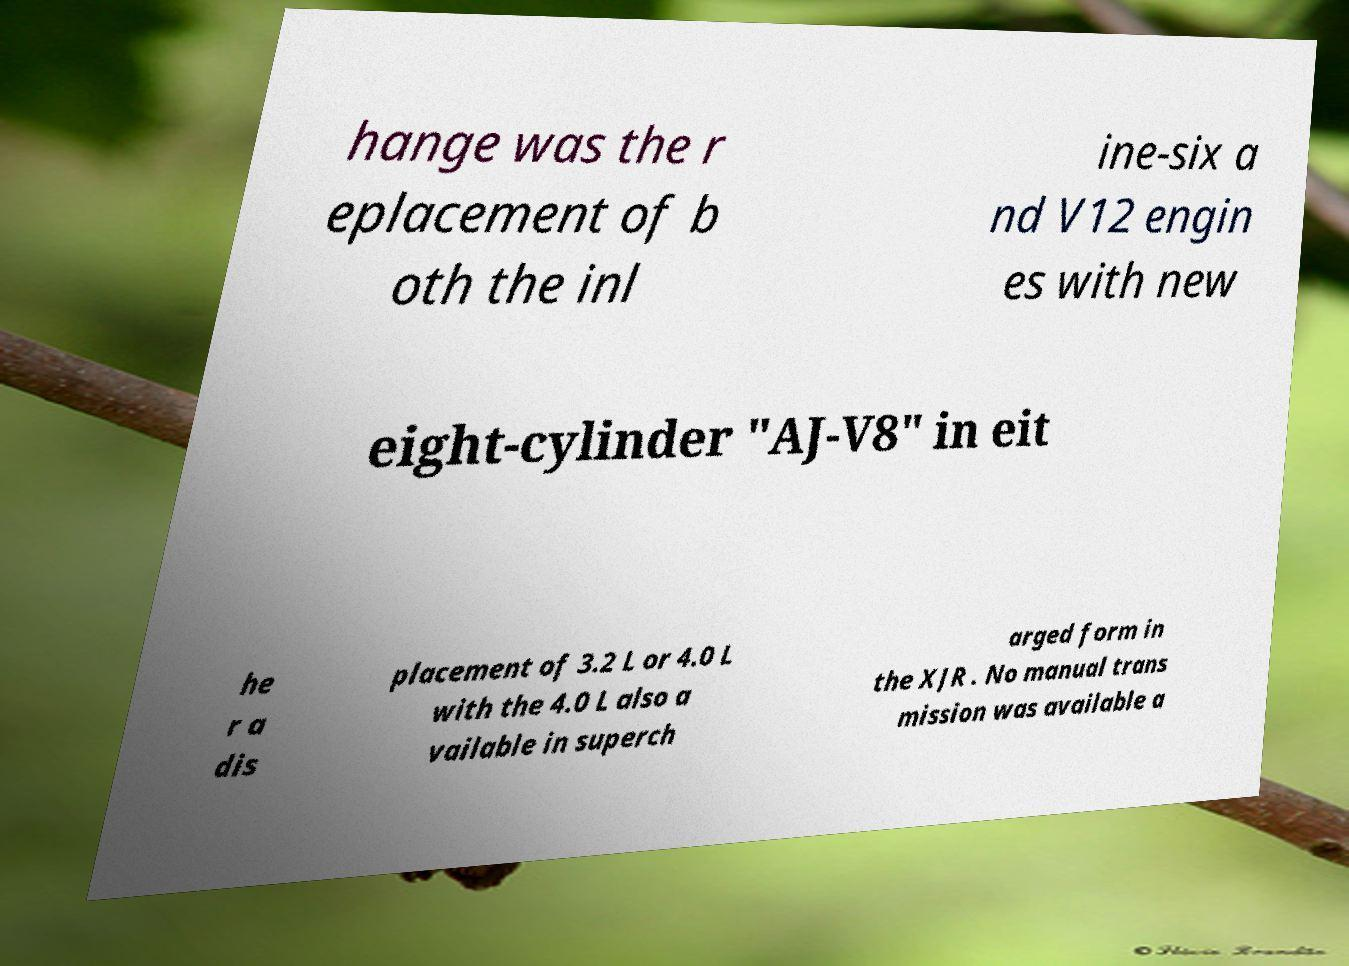Please read and relay the text visible in this image. What does it say? hange was the r eplacement of b oth the inl ine-six a nd V12 engin es with new eight-cylinder "AJ-V8" in eit he r a dis placement of 3.2 L or 4.0 L with the 4.0 L also a vailable in superch arged form in the XJR . No manual trans mission was available a 